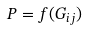Convert formula to latex. <formula><loc_0><loc_0><loc_500><loc_500>P = f ( G _ { i j } )</formula> 